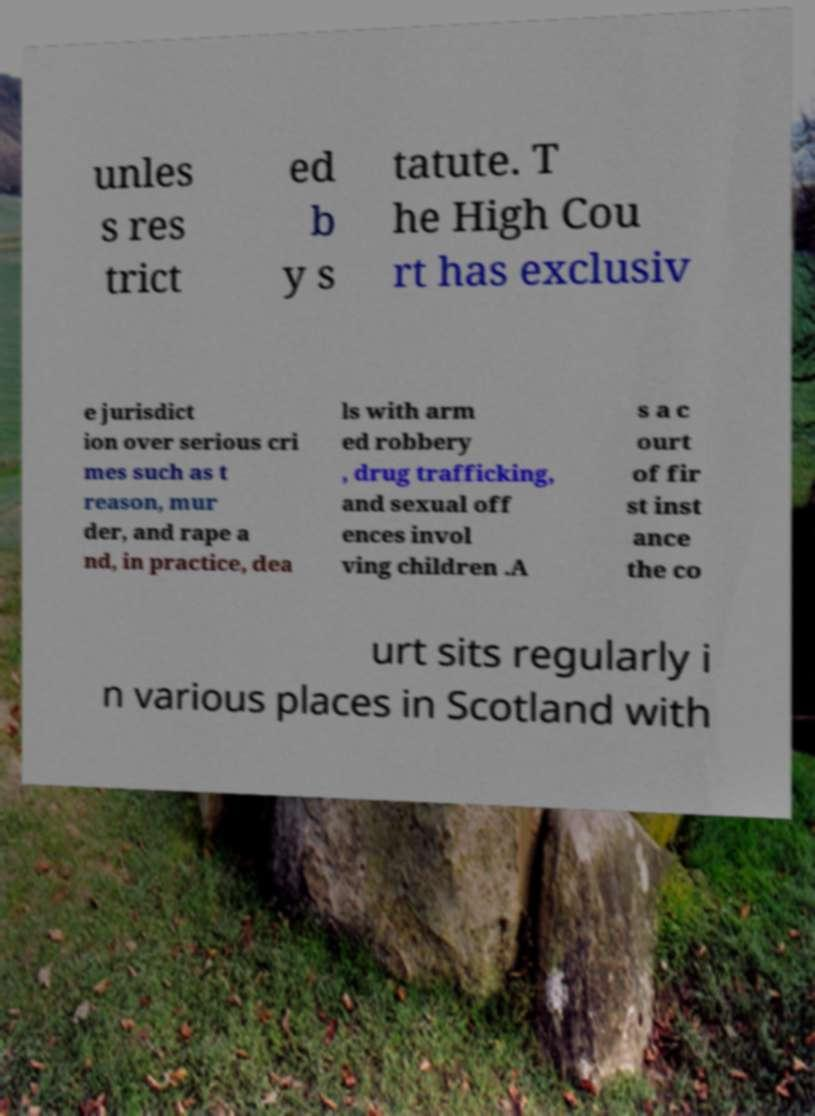Can you read and provide the text displayed in the image?This photo seems to have some interesting text. Can you extract and type it out for me? unles s res trict ed b y s tatute. T he High Cou rt has exclusiv e jurisdict ion over serious cri mes such as t reason, mur der, and rape a nd, in practice, dea ls with arm ed robbery , drug trafficking, and sexual off ences invol ving children .A s a c ourt of fir st inst ance the co urt sits regularly i n various places in Scotland with 